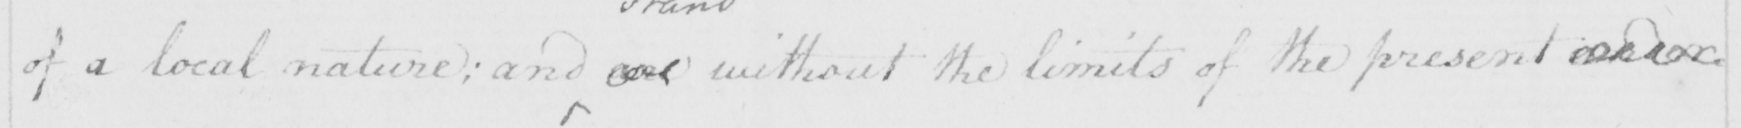What does this handwritten line say? of a local nature ; and are without the limits of the present under= 